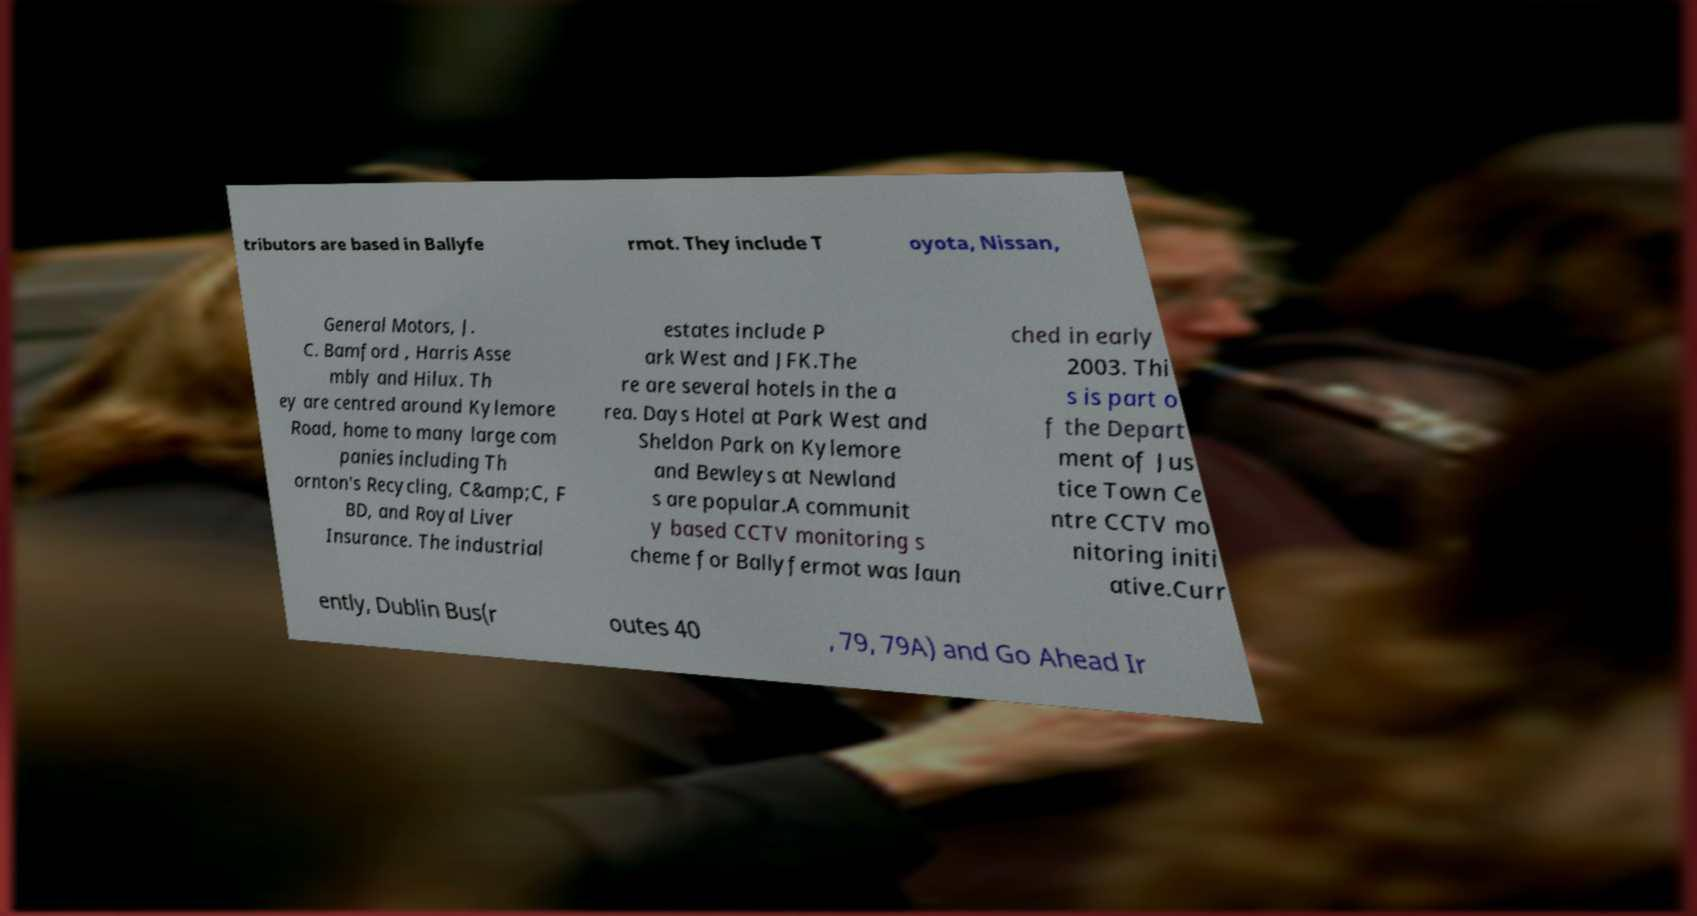Please identify and transcribe the text found in this image. tributors are based in Ballyfe rmot. They include T oyota, Nissan, General Motors, J. C. Bamford , Harris Asse mbly and Hilux. Th ey are centred around Kylemore Road, home to many large com panies including Th ornton's Recycling, C&amp;C, F BD, and Royal Liver Insurance. The industrial estates include P ark West and JFK.The re are several hotels in the a rea. Days Hotel at Park West and Sheldon Park on Kylemore and Bewleys at Newland s are popular.A communit y based CCTV monitoring s cheme for Ballyfermot was laun ched in early 2003. Thi s is part o f the Depart ment of Jus tice Town Ce ntre CCTV mo nitoring initi ative.Curr ently, Dublin Bus(r outes 40 , 79, 79A) and Go Ahead Ir 